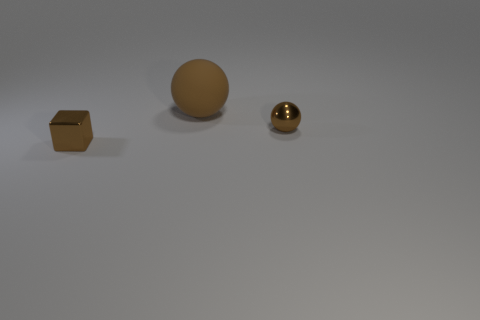Add 1 tiny brown metal spheres. How many objects exist? 4 Subtract all balls. How many objects are left? 1 Add 3 tiny metallic blocks. How many tiny metallic blocks are left? 4 Add 1 tiny objects. How many tiny objects exist? 3 Subtract 0 gray cylinders. How many objects are left? 3 Subtract all small metallic spheres. Subtract all large rubber objects. How many objects are left? 1 